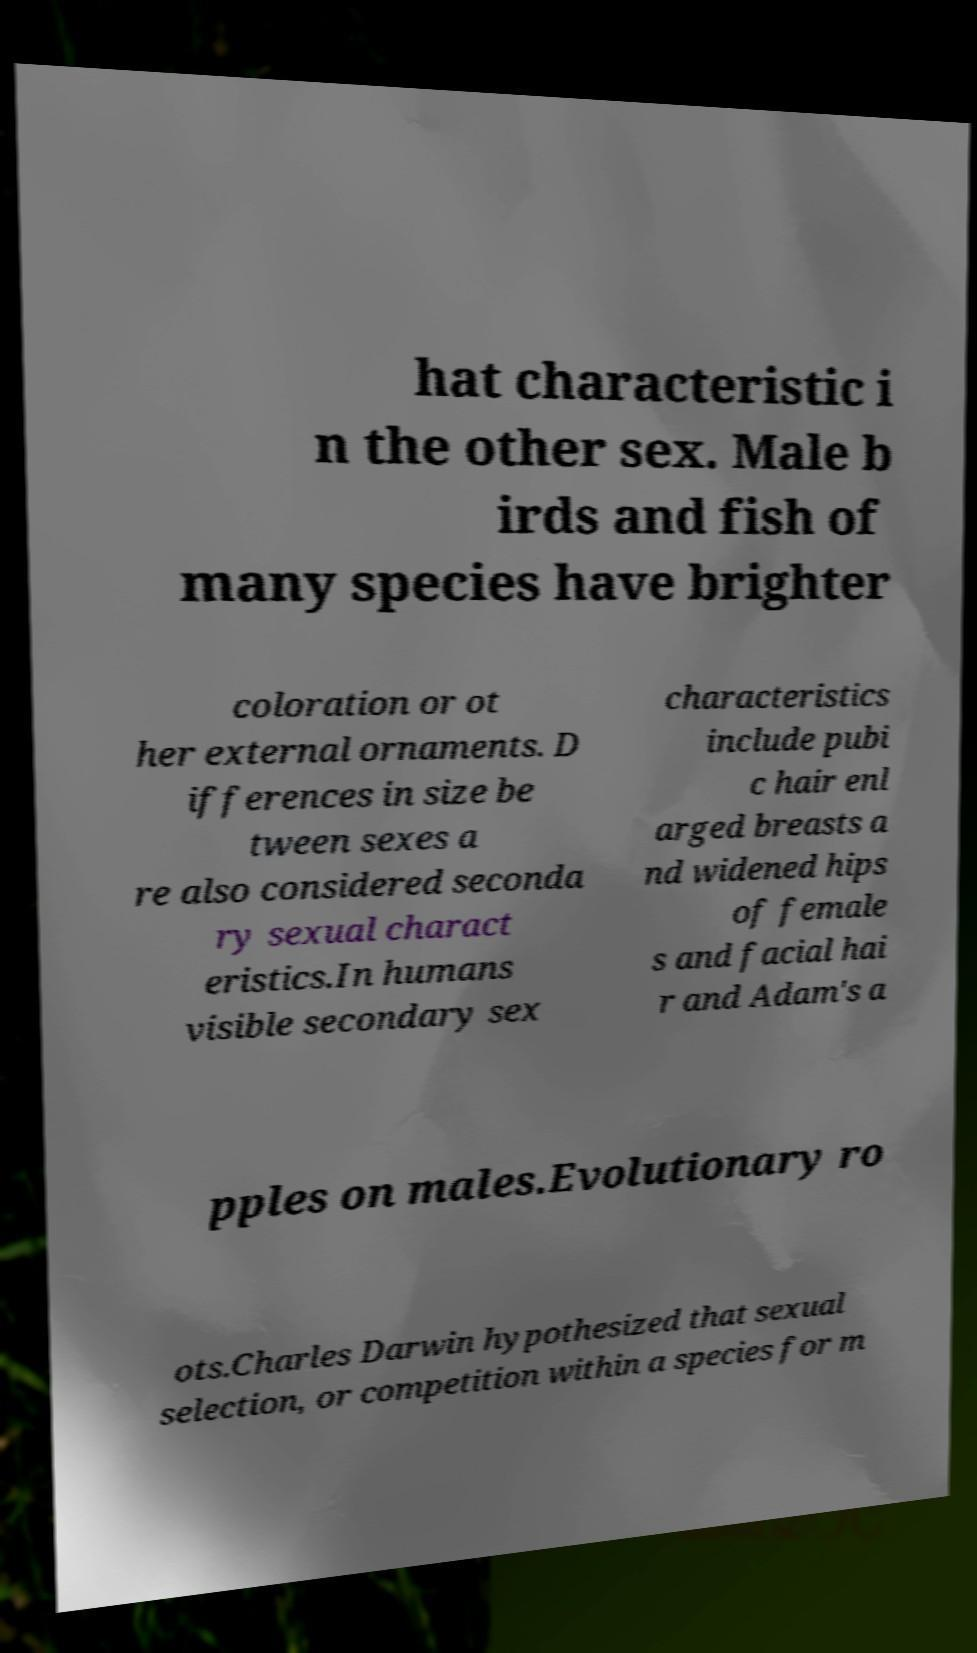What messages or text are displayed in this image? I need them in a readable, typed format. hat characteristic i n the other sex. Male b irds and fish of many species have brighter coloration or ot her external ornaments. D ifferences in size be tween sexes a re also considered seconda ry sexual charact eristics.In humans visible secondary sex characteristics include pubi c hair enl arged breasts a nd widened hips of female s and facial hai r and Adam's a pples on males.Evolutionary ro ots.Charles Darwin hypothesized that sexual selection, or competition within a species for m 